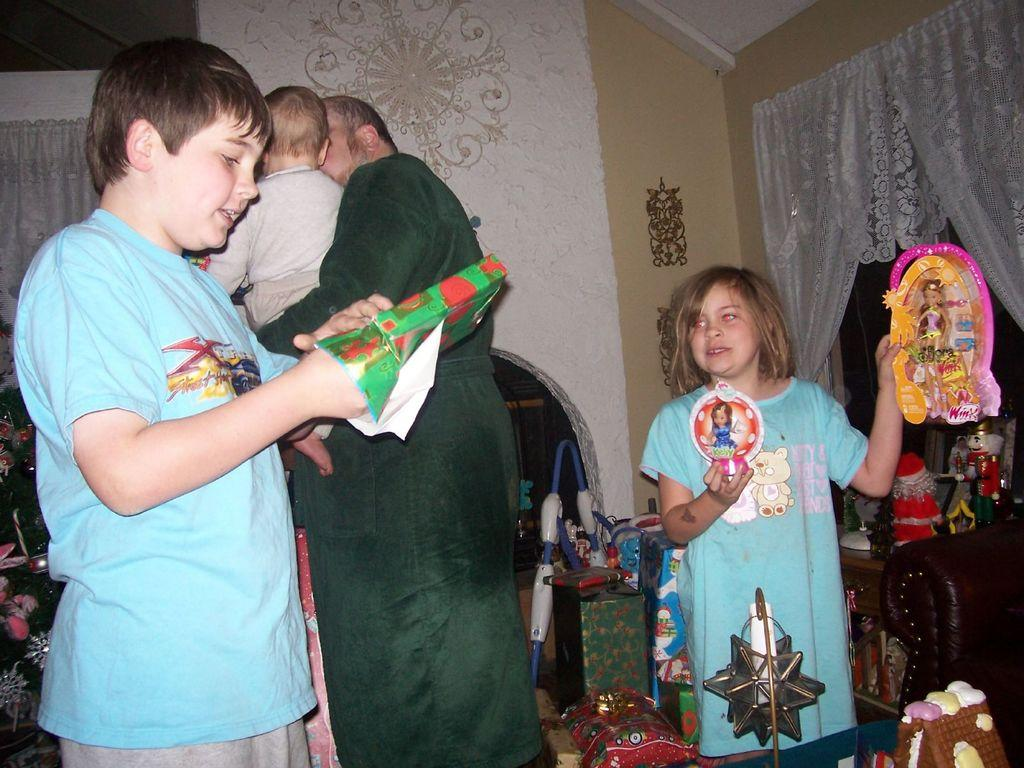Who is present in the image? There is a man and three kids in the image. What are the kids doing in the image? Two of the kids are holding objects in their hands. What can be seen in the background of the image? There is a wall in the background of the image. What type of window treatment is present in the image? There are curtains associated with the wall. What type of car is the laborer driving in the image? There is no car or laborer present in the image. 